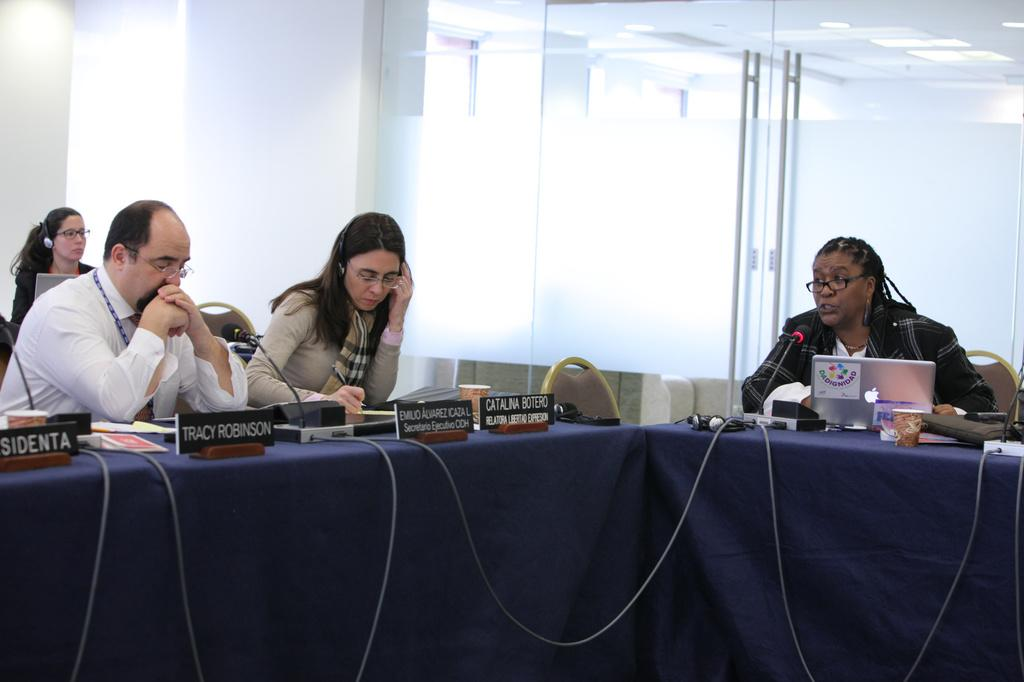What are the people in the image doing? The people in the image are sitting on chairs. Can you describe the furniture in the image? There is a door and a table in the image. What is on the table? There are mice and a laptop on the table. How many units of cattle can be seen in the image? There are no units of cattle present in the image. 